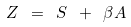Convert formula to latex. <formula><loc_0><loc_0><loc_500><loc_500>Z \ = \ S \ + \ \beta A</formula> 